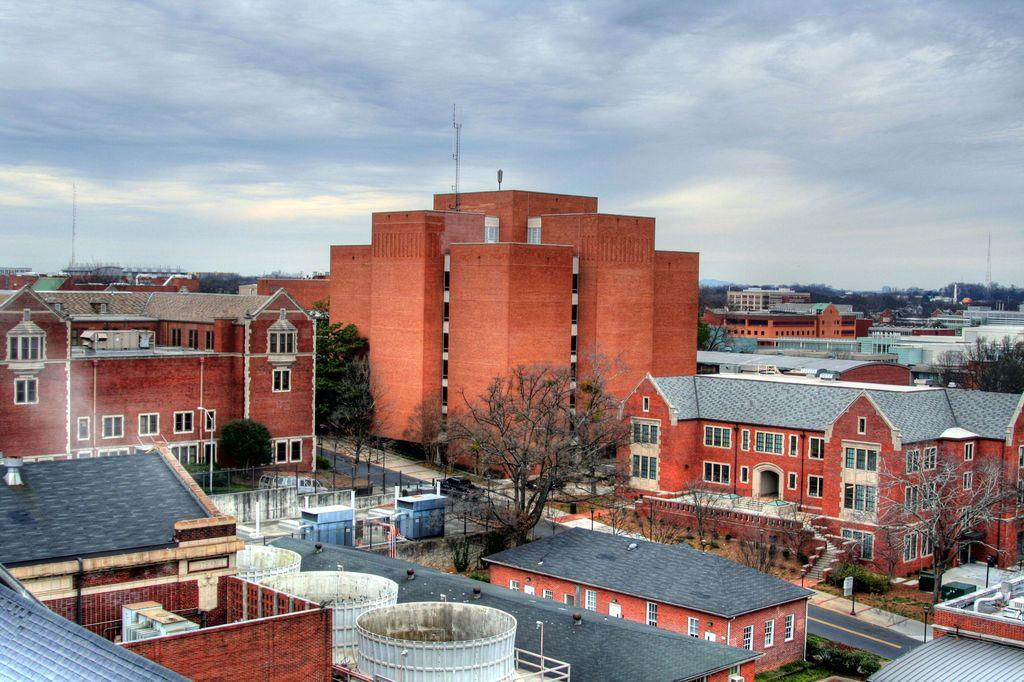What can be seen in the foreground of the image? There are houses and trees in the foreground of the image. What else is visible in the foreground besides the houses and trees? There are no other objects mentioned in the foreground. What can be seen in the background of the image? There are buildings, trees, and poles visible in the background of the image. What is visible at the very back of the image? The sky is visible in the background of the image. Who is the owner of the map in the image? There is no map present in the image. How many nails are visible in the image? There is no mention of nails in the provided facts, so we cannot determine if any are visible in the image. 